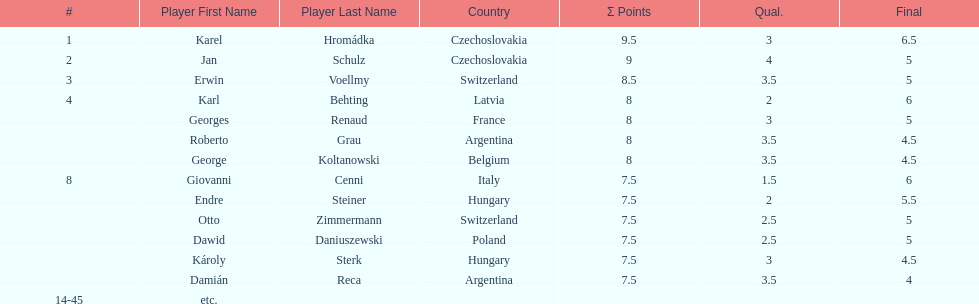Which player had the largest number of &#931; points? Karel Hromádka. 